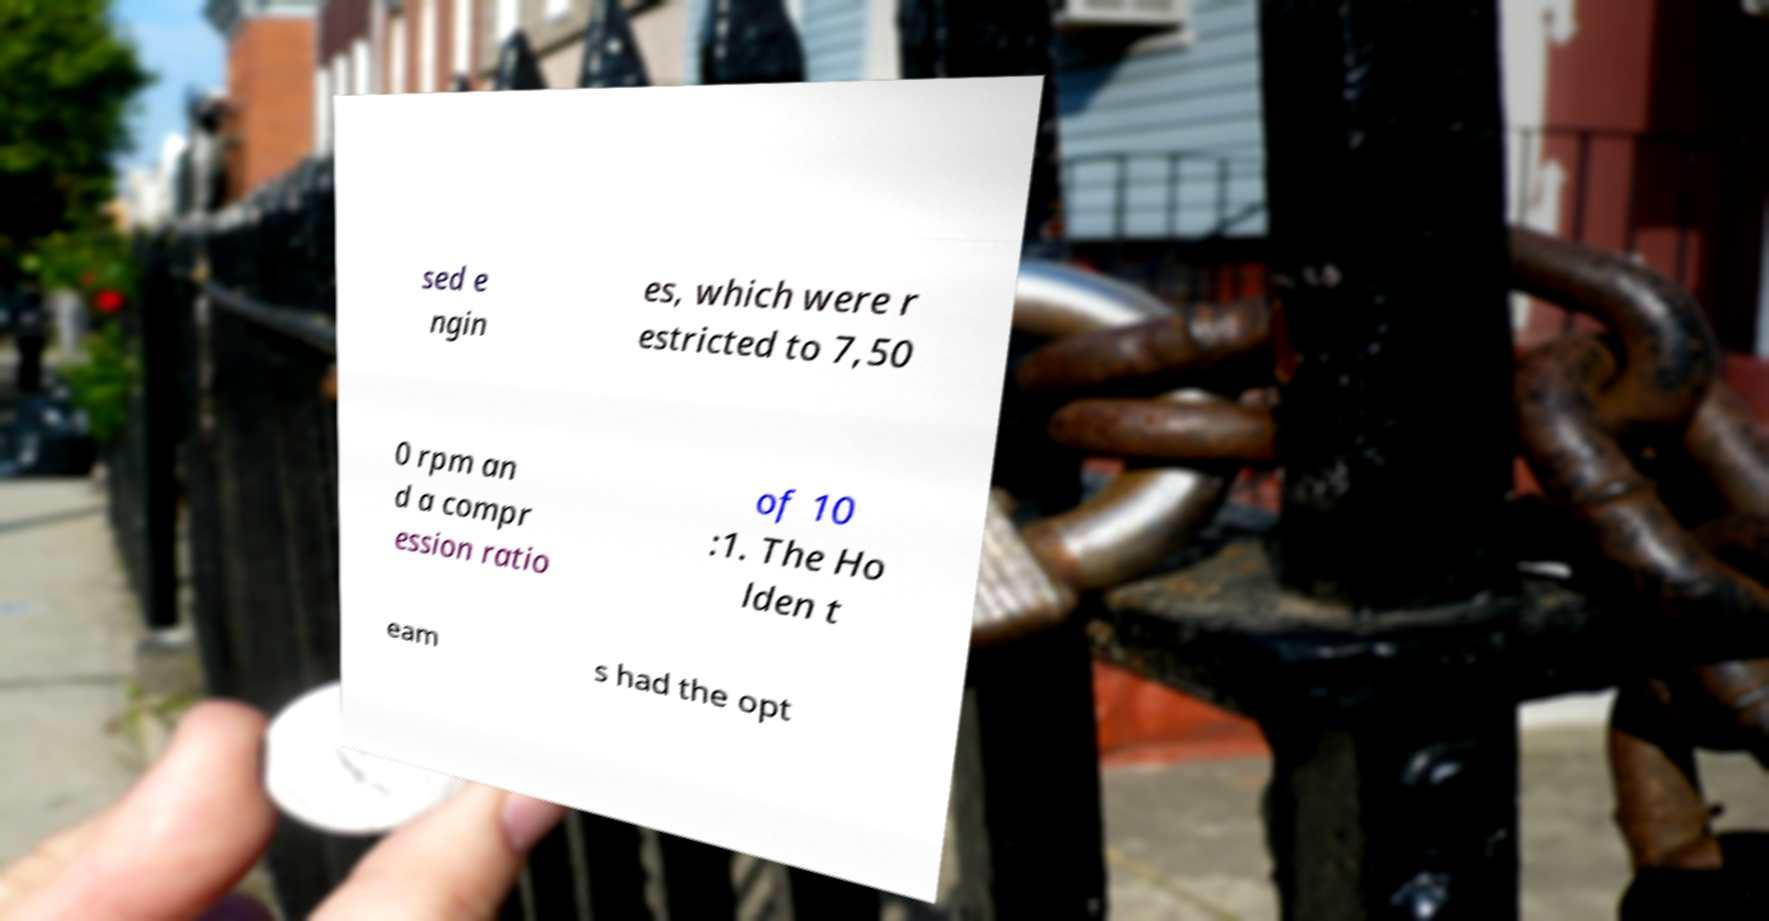Please identify and transcribe the text found in this image. sed e ngin es, which were r estricted to 7,50 0 rpm an d a compr ession ratio of 10 :1. The Ho lden t eam s had the opt 